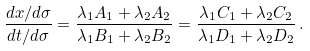Convert formula to latex. <formula><loc_0><loc_0><loc_500><loc_500>\frac { d x / d \sigma } { d t / d \sigma } = \frac { \lambda _ { 1 } A _ { 1 } + \lambda _ { 2 } A _ { 2 } } { \lambda _ { 1 } B _ { 1 } + \lambda _ { 2 } B _ { 2 } } = \frac { \lambda _ { 1 } C _ { 1 } + \lambda _ { 2 } C _ { 2 } } { \lambda _ { 1 } D _ { 1 } + \lambda _ { 2 } D _ { 2 } } \, .</formula> 